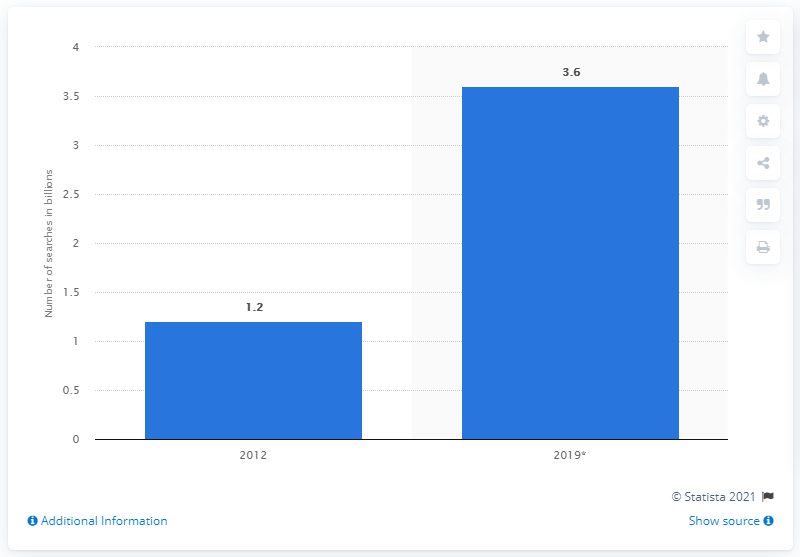Identify some key points in this picture. In 2012, the number of searches using Kayak was 1.2. The number of searches using Kayak's forecast to increase in 2019 was 3.6... 